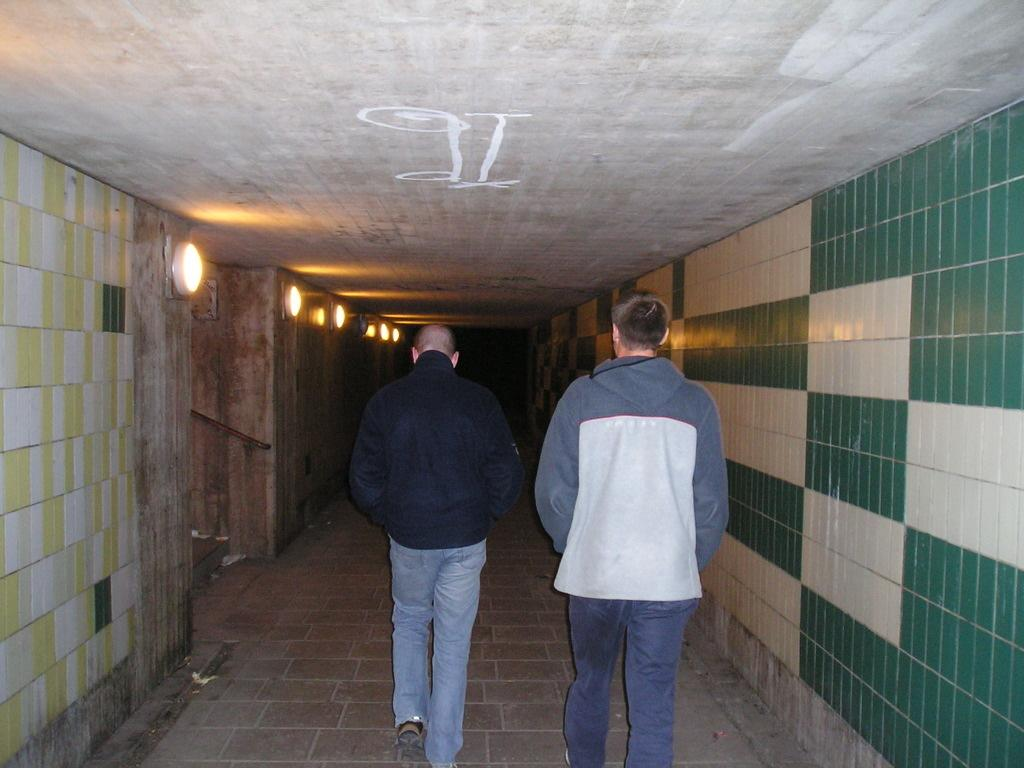What are the two persons in the image doing? The two persons in the image are walking. On what surface are the persons walking? The persons are walking on the floor. What can be seen on both sides of the image? There are walls on both the right and left sides of the image. What is visible on the left side of the image? There are lights on the left side of the image. How many babies are crawling on the floor in the image? There are no babies present in the image; it features two persons walking. What type of snails can be seen moving on the walls in the image? There are no snails present in the image; it only shows two persons walking and the surrounding environment. 